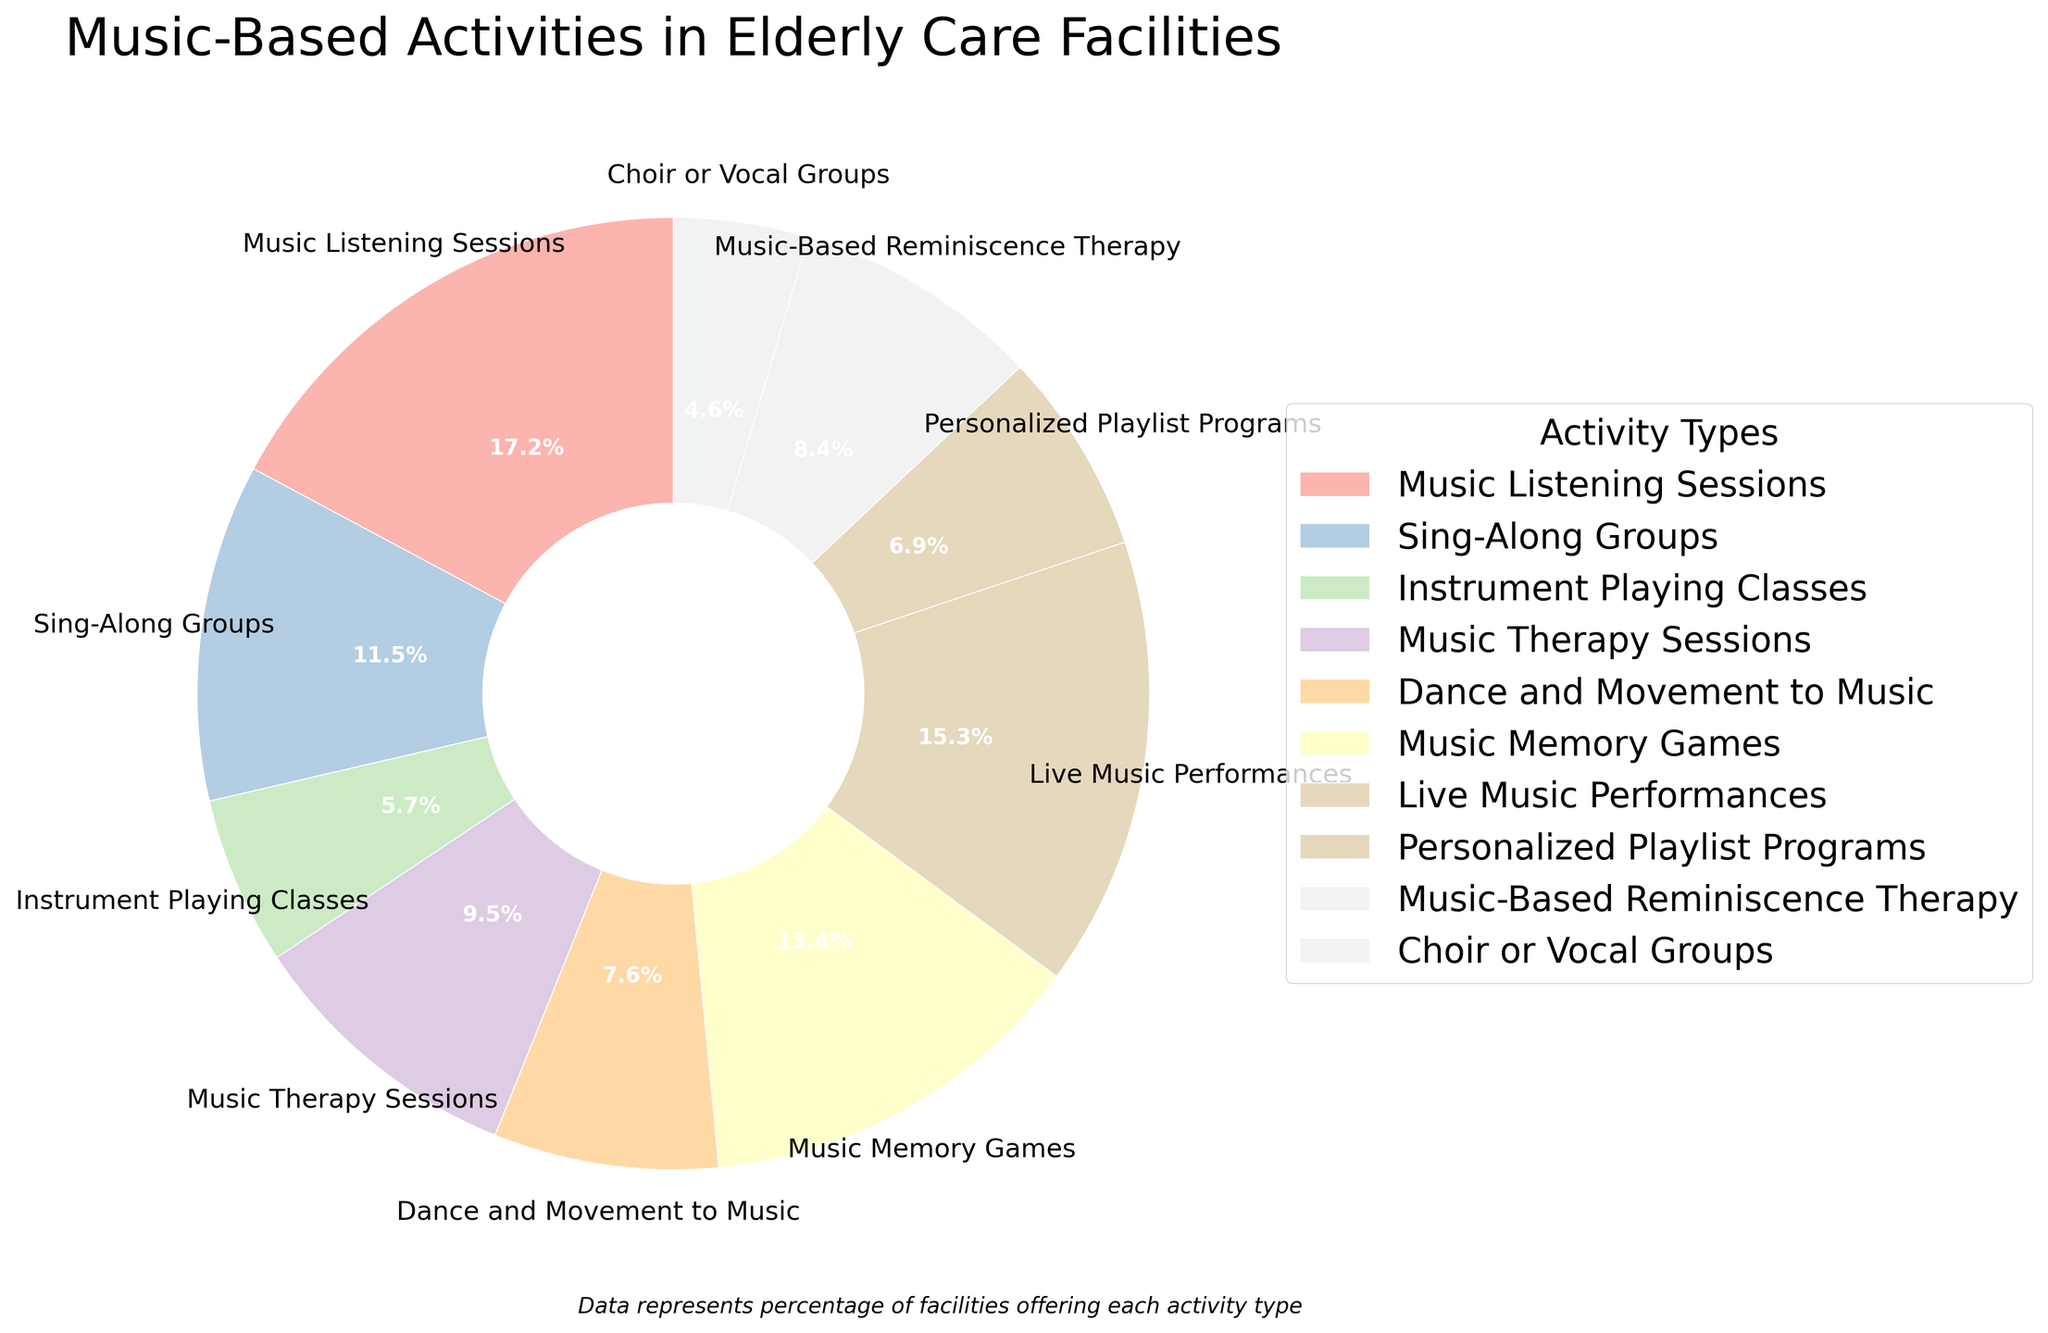Which music-based activity is offered by the highest percentage of elderly care facilities? The activity offered by the highest percentage can be determined by looking at the segment in the pie chart with the largest size and its associated label. The largest segment corresponds to Music Listening Sessions.
Answer: Music Listening Sessions What is the percentage difference between the highest and lowest offered music-based activities? The highest percentage is for Music Listening Sessions at 45%, and the lowest is for Choir or Vocal Groups at 12%. The difference is calculated by subtracting 12% from 45%.
Answer: 33% How many activities are offered by at least 20% of elderly care facilities? By examining the pie chart, we count the segments with a percentage label of 20% or higher: Music Listening Sessions (45%), Sing-Along Groups (30%), Live Music Performances (40%), Music Memory Games (35%), Music Therapy Sessions (25%), and Dance and Movement to Music (20%). This results in six activities.
Answer: 6 Which two activities combined account for 65% of the facilities' offerings? To find the combined percentage, we look for two segments whose summed values equal 65%. Music Listening Sessions (45%) and Music Memory Games (20%) together add up to 65%.
Answer: Music Listening Sessions and Music Memory Games What is the combined percentage of activities related to direct music interaction (singing, playing instruments, or performing)? Summing the percentages of Sing-Along Groups (30%), Instrument Playing Classes (15%), and Live Music Performances (40%) gives the total. Calculation: 30% + 15% + 40% = 85%.
Answer: 85% Are more facilities offering Music Therapy Sessions or Personalized Playlist Programs? By comparing the percentages, Music Therapy Sessions are offered by 25%, while Personalized Playlist Programs are offered by 18%. The higher percentage corresponds to Music Therapy Sessions.
Answer: Music Therapy Sessions Which activity is offered by exactly three-quarters of facilities when compared to the most offered activity? The most offered activity, Music Listening Sessions, is offered by 45%. Three-quarters of 45% is 33.75%, rounded to the nearest value in the pie chart, which is Sing-Along Groups at 30%.
Answer: Sing-Along Groups Among the activities with over 30% offerings, which one is visually closest in size to Music Therapy Sessions? The segments over 30% are Music Listening Sessions (45%), Sing-Along Groups (30%), Music Memory Games (35%), and Live Music Performances (40%). Among them, Sing-Along Groups at 30% is closest in size to Music Therapy Sessions at 25%.
Answer: Sing-Along Groups Looking at visual representations, which two activities have visually similar segment sizes? The visually similar segment sizes can be observed between Personalized Playlist Programs (18%) and Music-Based Reminiscence Therapy (22%).
Answer: Personalized Playlist Programs and Music-Based Reminiscence Therapy 